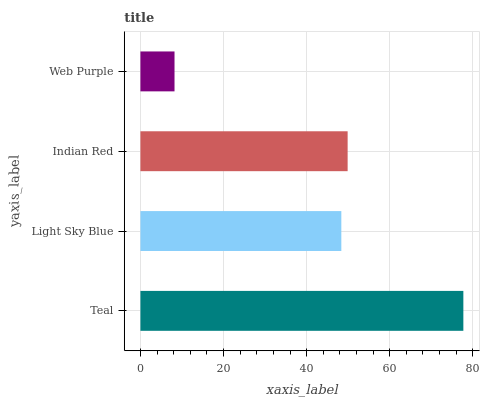Is Web Purple the minimum?
Answer yes or no. Yes. Is Teal the maximum?
Answer yes or no. Yes. Is Light Sky Blue the minimum?
Answer yes or no. No. Is Light Sky Blue the maximum?
Answer yes or no. No. Is Teal greater than Light Sky Blue?
Answer yes or no. Yes. Is Light Sky Blue less than Teal?
Answer yes or no. Yes. Is Light Sky Blue greater than Teal?
Answer yes or no. No. Is Teal less than Light Sky Blue?
Answer yes or no. No. Is Indian Red the high median?
Answer yes or no. Yes. Is Light Sky Blue the low median?
Answer yes or no. Yes. Is Teal the high median?
Answer yes or no. No. Is Web Purple the low median?
Answer yes or no. No. 